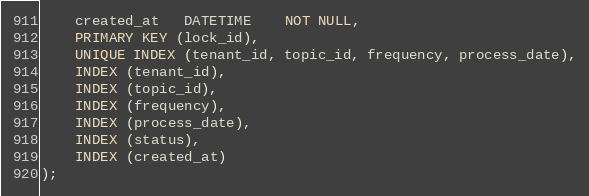<code> <loc_0><loc_0><loc_500><loc_500><_SQL_>    created_at   DATETIME    NOT NULL,
    PRIMARY KEY (lock_id),
    UNIQUE INDEX (tenant_id, topic_id, frequency, process_date),
    INDEX (tenant_id),
    INDEX (topic_id),
    INDEX (frequency),
    INDEX (process_date),
    INDEX (status),
    INDEX (created_at)
);
</code> 